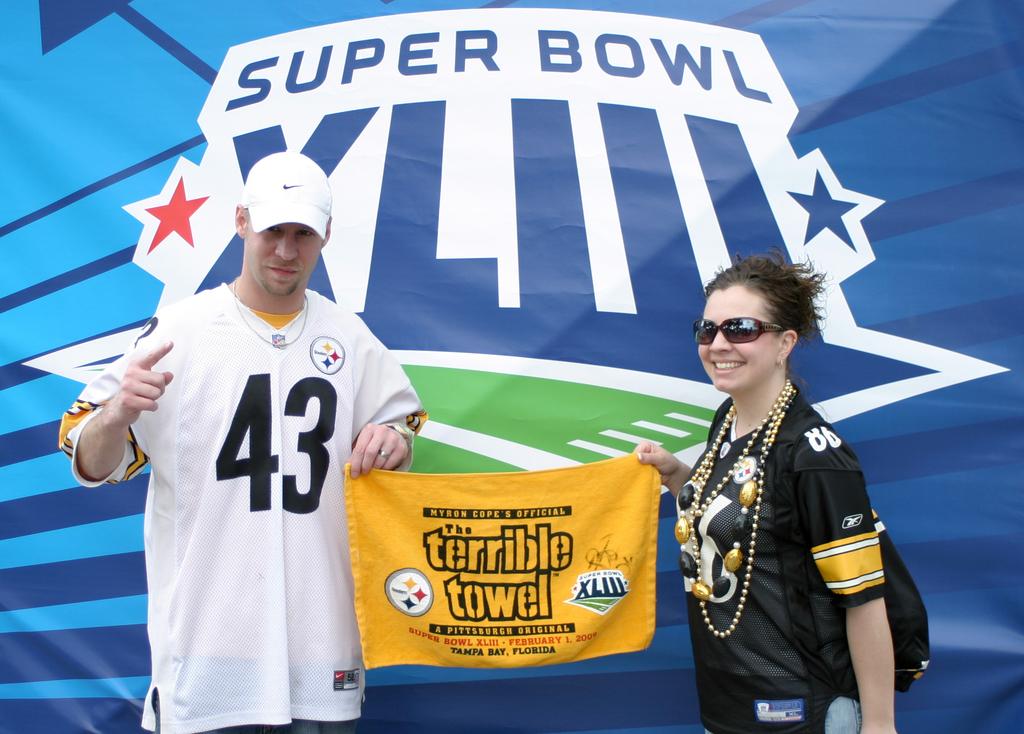What sporting event is advertised on the background?
Your response must be concise. Super bowl. 